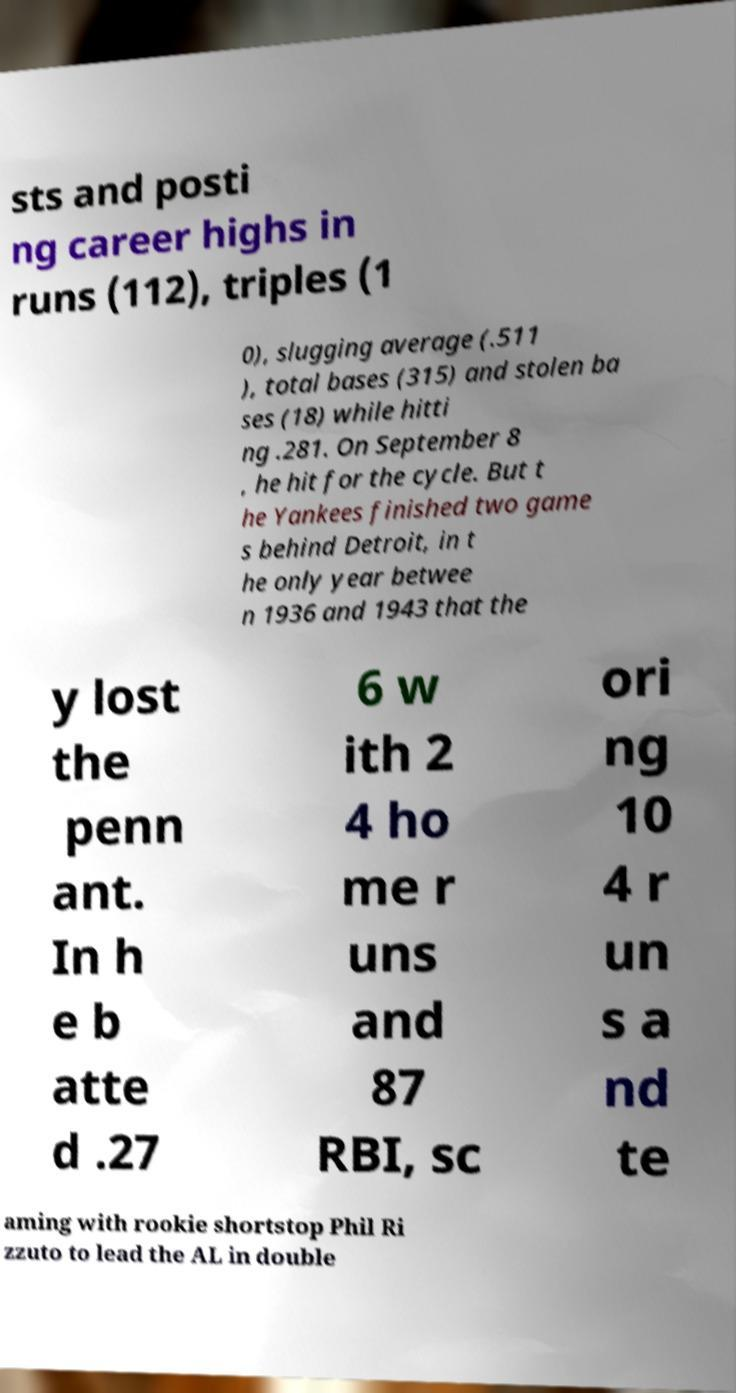Please read and relay the text visible in this image. What does it say? sts and posti ng career highs in runs (112), triples (1 0), slugging average (.511 ), total bases (315) and stolen ba ses (18) while hitti ng .281. On September 8 , he hit for the cycle. But t he Yankees finished two game s behind Detroit, in t he only year betwee n 1936 and 1943 that the y lost the penn ant. In h e b atte d .27 6 w ith 2 4 ho me r uns and 87 RBI, sc ori ng 10 4 r un s a nd te aming with rookie shortstop Phil Ri zzuto to lead the AL in double 